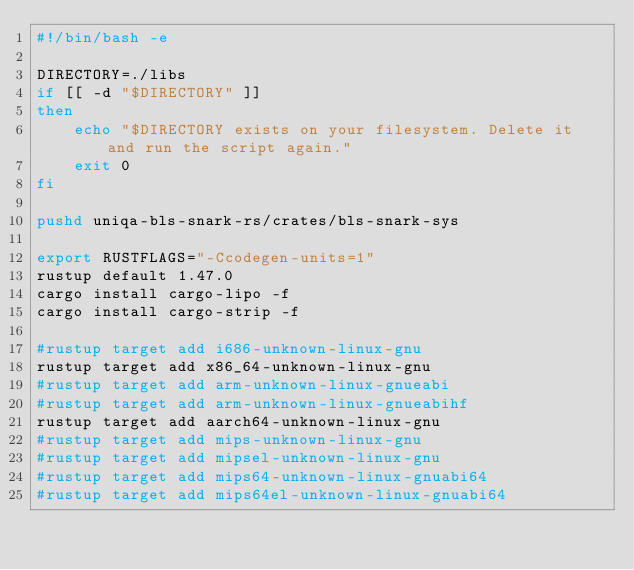Convert code to text. <code><loc_0><loc_0><loc_500><loc_500><_Bash_>#!/bin/bash -e

DIRECTORY=./libs
if [[ -d "$DIRECTORY" ]]
then
    echo "$DIRECTORY exists on your filesystem. Delete it and run the script again."
    exit 0
fi

pushd uniqa-bls-snark-rs/crates/bls-snark-sys

export RUSTFLAGS="-Ccodegen-units=1"
rustup default 1.47.0
cargo install cargo-lipo -f
cargo install cargo-strip -f

#rustup target add i686-unknown-linux-gnu
rustup target add x86_64-unknown-linux-gnu
#rustup target add arm-unknown-linux-gnueabi
#rustup target add arm-unknown-linux-gnueabihf
rustup target add aarch64-unknown-linux-gnu
#rustup target add mips-unknown-linux-gnu
#rustup target add mipsel-unknown-linux-gnu
#rustup target add mips64-unknown-linux-gnuabi64
#rustup target add mips64el-unknown-linux-gnuabi64</code> 